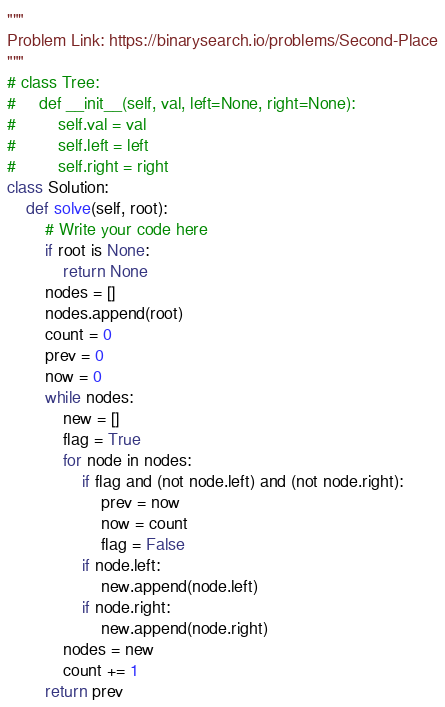Convert code to text. <code><loc_0><loc_0><loc_500><loc_500><_Python_>"""
Problem Link: https://binarysearch.io/problems/Second-Place
"""
# class Tree:
#     def __init__(self, val, left=None, right=None):
#         self.val = val
#         self.left = left
#         self.right = right
class Solution:
    def solve(self, root):
        # Write your code here
        if root is None:
            return None 
        nodes = []
        nodes.append(root)
        count = 0 
        prev = 0 
        now = 0
        while nodes:
            new = []
            flag = True 
            for node in nodes:
                if flag and (not node.left) and (not node.right):
                    prev = now 
                    now = count 
                    flag = False
                if node.left:
                    new.append(node.left)
                if node.right:
                    new.append(node.right)
            nodes = new 
            count += 1 
        return prev 
</code> 